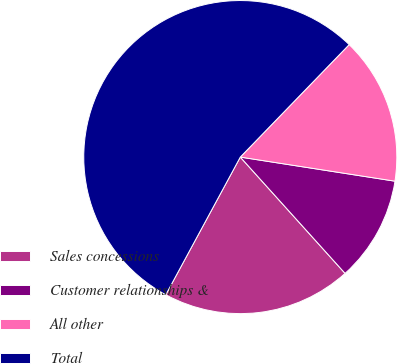Convert chart. <chart><loc_0><loc_0><loc_500><loc_500><pie_chart><fcel>Sales concessions<fcel>Customer relationships &<fcel>All other<fcel>Total<nl><fcel>19.57%<fcel>10.87%<fcel>15.22%<fcel>54.35%<nl></chart> 